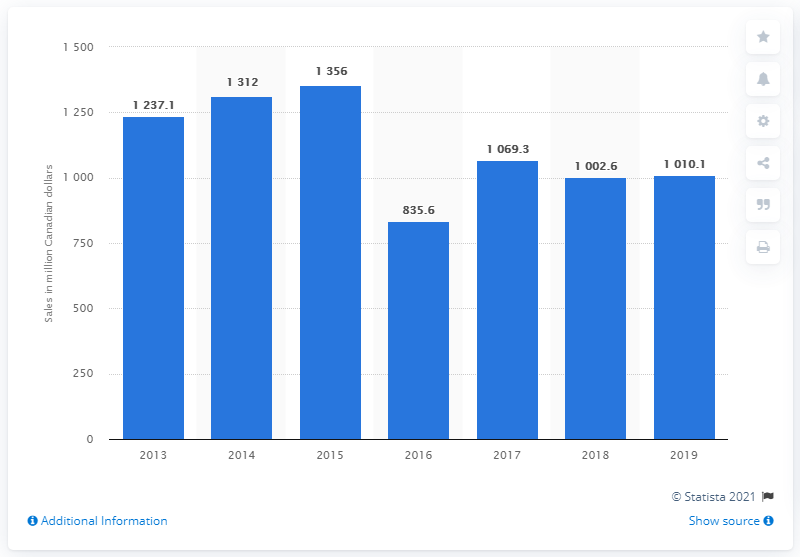Identify some key points in this picture. Anheuser-Busch InBev's estimated sales in Canada in 2019 were 1010.1 million. 